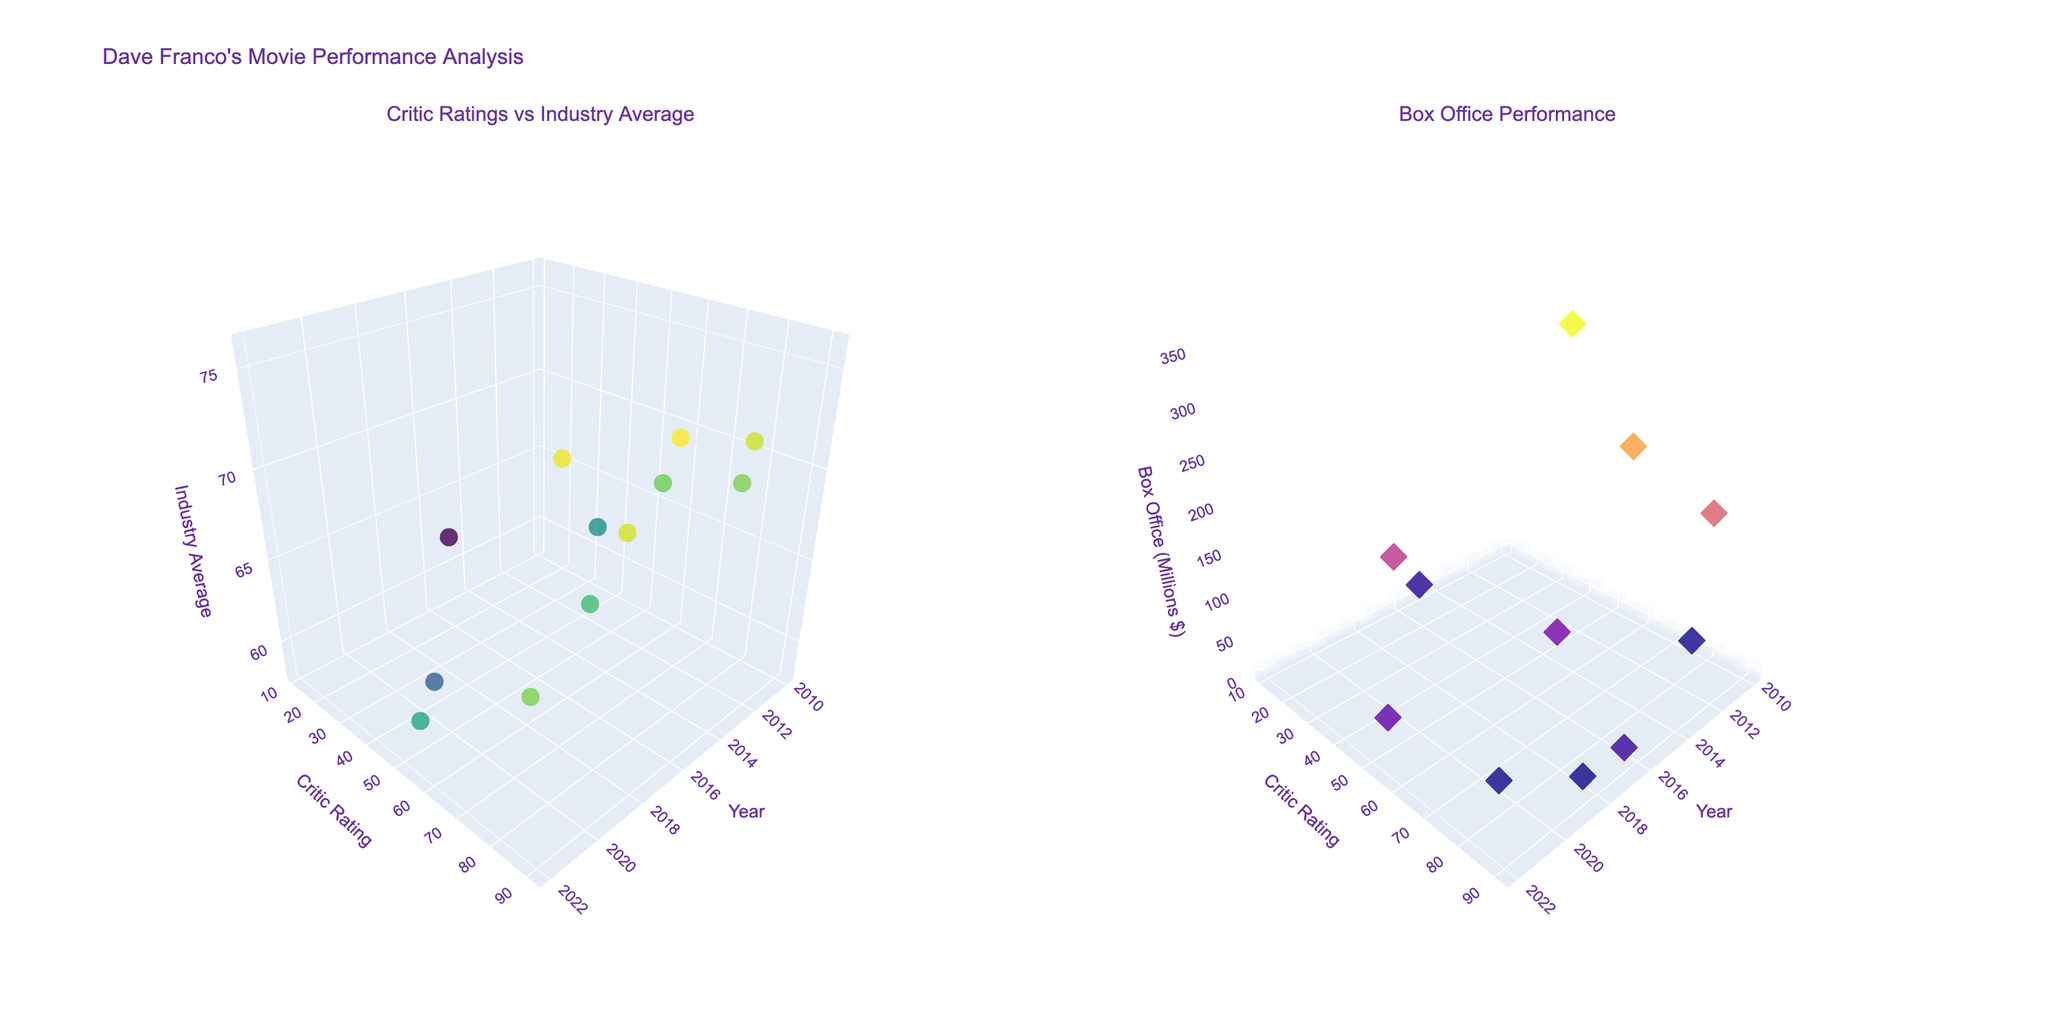What's the title of the figure? The title is at the top of the figure and provides a summary of what the visualizations are about. The title in this case is "Dave Franco's Movie Performance Analysis."
Answer: Dave Franco's Movie Performance Analysis Which subplot shows the relationship between Critic Ratings and Industry Average? The subplot titles are provided above each subplot. The first subplot titled "Critic Ratings vs Industry Average" shows this relationship.
Answer: The first subplot What color scale is used for the markers in the first subplot? The color scale used in the first subplot can be determined by looking at the color gradient applied to the markers. In this case, it's the 'Viridis' color scale.
Answer: Viridis How many movies were rated in 2014, and what was the critic rating? By counting the data points labeled with the year 2014, we can see there's one movie. The critic rating for that movie (Neighbors) is 73.
Answer: One movie, 73 What was the box office performance of the movie 'Now You See Me' in 2013? Locate the data point corresponding to 'Now You See Me' on the second subplot and read the value on the 'Box Office Performance' axis (z-axis). The box office performance in 2013 was 351.7 million dollars.
Answer: 351.7 million dollars Which year had the movie with the highest critic rating, and what was the rating? By identifying the highest point on the Critic Rating axis in the first subplot, we can see that the year with the highest critic rating is 2017 for the movie 'The Disaster Artist' with a rating of 91.
Answer: 2017, 91 How does 'Day Shift' in 2022 compare in critic rating to 'Nerve' in 2016? Observe the Critic Ratings for both years; 'Day Shift' (2022) has a rating of 57, while 'Nerve' (2016) has a rating of 66. 'Nerve' has a higher critic rating.
Answer: 'Nerve' has a higher rating What is the average box office performance of Dave Franco's movies in the years where he had above industry average critic ratings? First, identify the years where Critic Rating is above Industry Average in the first subplot. Only the movies '21 Jump Street,' 'Neighbors,’ ‘The Disaster Artist,’ ‘6 Balloons,’ and 'The Rental' meet this criterion, with box office values of 201.6, 270.7, 29.8, 0.1, and 2.1 million dollars respectively. Calculate their average: (201.6 + 270.7 + 29.8 + 0.1 + 2.1) / 5 = 100.86 million dollars.
Answer: 100.86 million dollars What was the critic rating for the movie released in 2010, and how does it compare to the industry average that year? Locate the data point for the movie 'Greenberg' in 2010 in the first subplot; the critic rating is 75 and the industry average is 68. 'Greenberg' has a higher rating than the industry average.
Answer: 75, higher than the industry average 